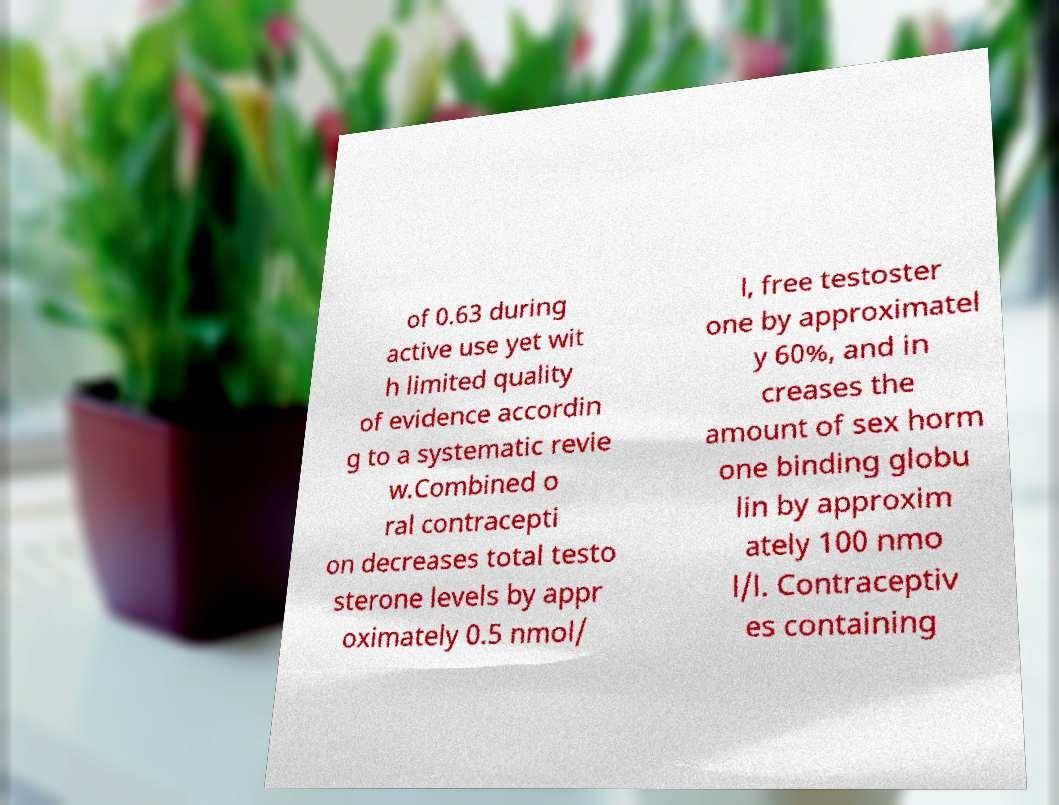Please read and relay the text visible in this image. What does it say? of 0.63 during active use yet wit h limited quality of evidence accordin g to a systematic revie w.Combined o ral contracepti on decreases total testo sterone levels by appr oximately 0.5 nmol/ l, free testoster one by approximatel y 60%, and in creases the amount of sex horm one binding globu lin by approxim ately 100 nmo l/l. Contraceptiv es containing 